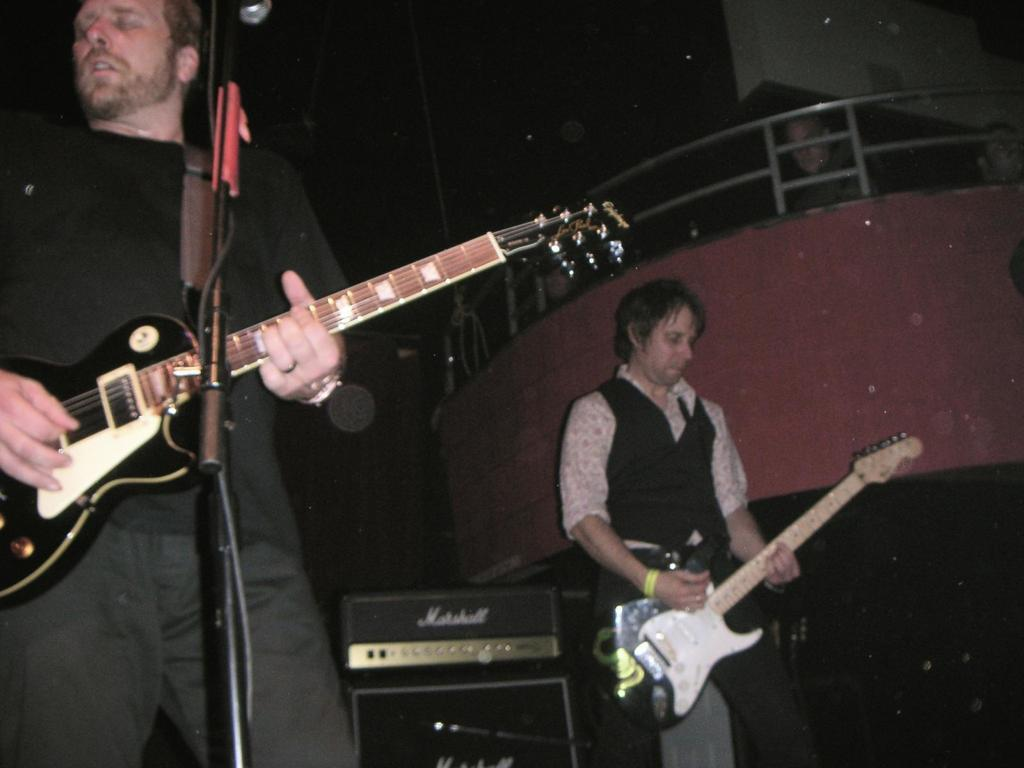How many people are in the image? There are two people in the image. What are the people holding in the image? Both people are holding guitars. Can you describe the presence of a microphone in the image? There is a microphone in front of one of the people. What type of leather is being used to cover the stove in the image? There is no stove or leather present in the image. What kind of arch can be seen in the background of the image? There is no arch visible in the image. 